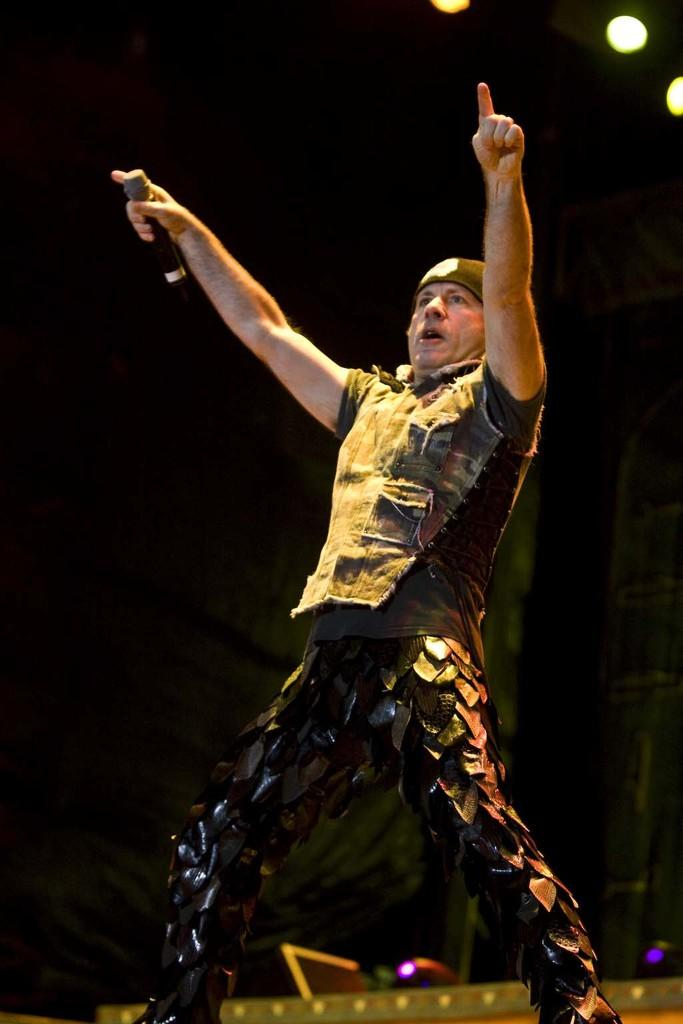What is the main subject of the image? There is a man in the image. What is the man doing in the image? The man is standing in the image. What object is the man holding in his hand? The man is holding a microphone in his hand. What can be seen in the background of the image? There is a black curtain in the background of the image. What type of crayon is the man using to write on the vessel in the image? There is no vessel or crayon present in the image. The man is holding a microphone, not a crayon, and there is no vessel in the image. 